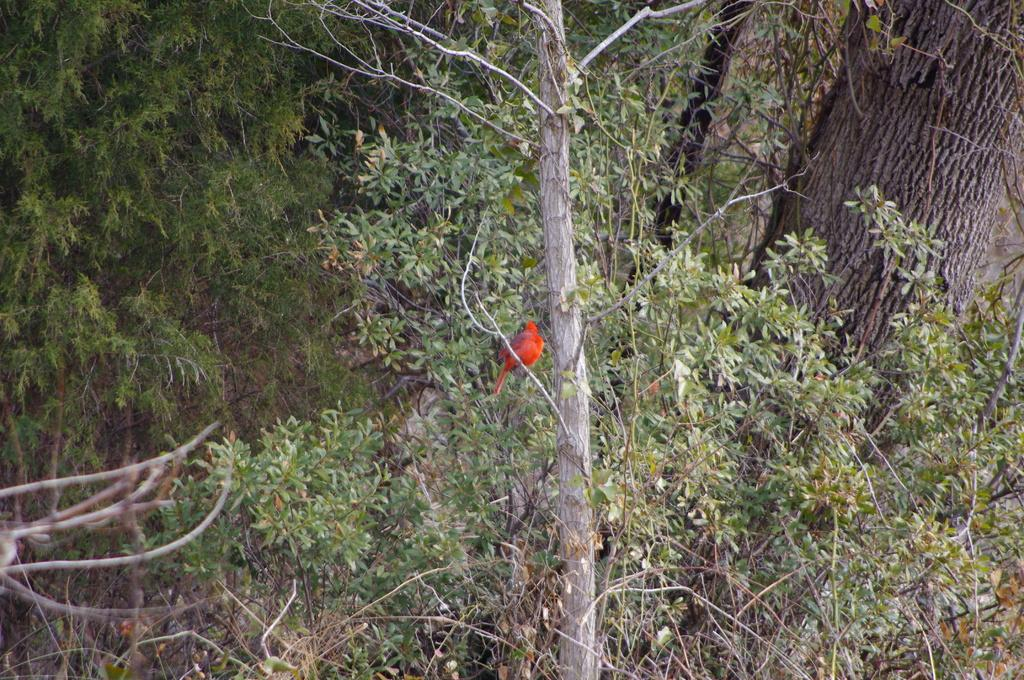What type of living organisms can be seen in the image? Plants can be seen in the image. What object is present that might be used for carrying or storing items? There is a trunk in the image. What type of animal can be seen in the image? There is a bird in the image. What type of harmony is being played by the band in the image? There is no band present in the image, so it is not possible to determine what type of harmony might be played. 